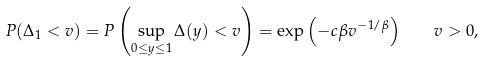<formula> <loc_0><loc_0><loc_500><loc_500>P ( \Delta _ { 1 } < v ) = P \left ( \sup _ { 0 \leq y \leq 1 } \Delta ( y ) < v \right ) = \exp \left ( - c \beta v ^ { - 1 / \beta } \right ) \quad v > 0 ,</formula> 